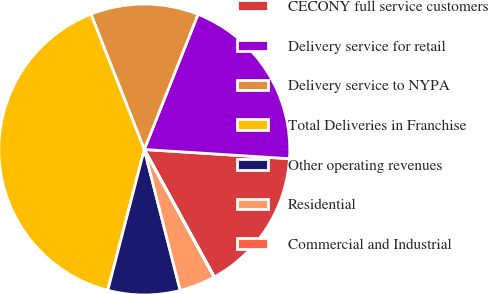Convert chart. <chart><loc_0><loc_0><loc_500><loc_500><pie_chart><fcel>CECONY full service customers<fcel>Delivery service for retail<fcel>Delivery service to NYPA<fcel>Total Deliveries in Franchise<fcel>Other operating revenues<fcel>Residential<fcel>Commercial and Industrial<nl><fcel>16.0%<fcel>19.99%<fcel>12.0%<fcel>39.98%<fcel>8.01%<fcel>4.01%<fcel>0.01%<nl></chart> 